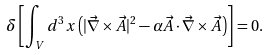<formula> <loc_0><loc_0><loc_500><loc_500>\delta \left [ \int _ { V } d ^ { 3 } x \left ( | \vec { \nabla } \times \vec { A } | ^ { 2 } - \alpha \vec { A } \cdot \vec { \nabla } \times \vec { A } \right ) \right ] = 0 .</formula> 